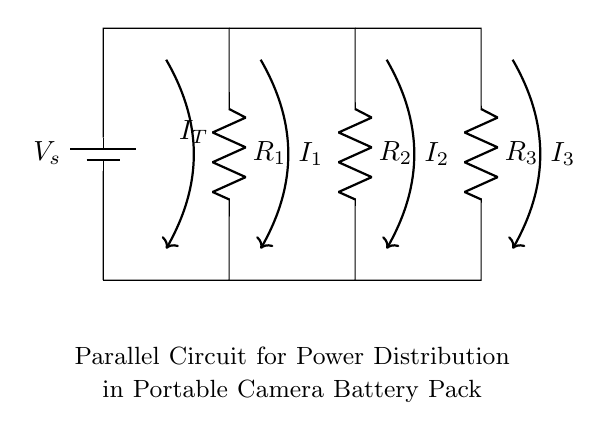What is the total current entering the circuit? The total current entering the circuit is represented by I_T, which is the sum of the individual currents flowing through the resistors R1, R2, and R3.
Answer: I_T What are the values of the resistors in the circuit? The resistors R1, R2, and R3 are part of the parallel circuit; however, their specific numerical values are not provided in the diagram, only that they are labeled as R1, R2, and R3.
Answer: R1, R2, R3 How is the voltage in this circuit defined? The voltage across every resistor in this parallel circuit is the same as the source voltage V_s from the battery, as they are connected directly across it.
Answer: V_s What is the role of the current divider in this circuit? The current divider allows the total current I_T to be split among the parallel resistors (R1, R2, and R3) based on their resistance values.
Answer: Splitting current Which resistor will carry the most current? The current through each resistor is inversely proportional to its resistance; therefore, the resistor with the least resistance will carry the most current.
Answer: The one with the least resistance How many resistors are used in this circuit? The parallel circuit contains three resistors, labeled R1, R2, and R3. Counting them directly from the circuit diagram confirms this.
Answer: Three What is the purpose of this parallel circuit in relation to camera equipment? The parallel circuit is designed to manage power distribution in a portable battery pack for camera equipment, ensuring that power is supplied to multiple components simultaneously.
Answer: Power distribution 